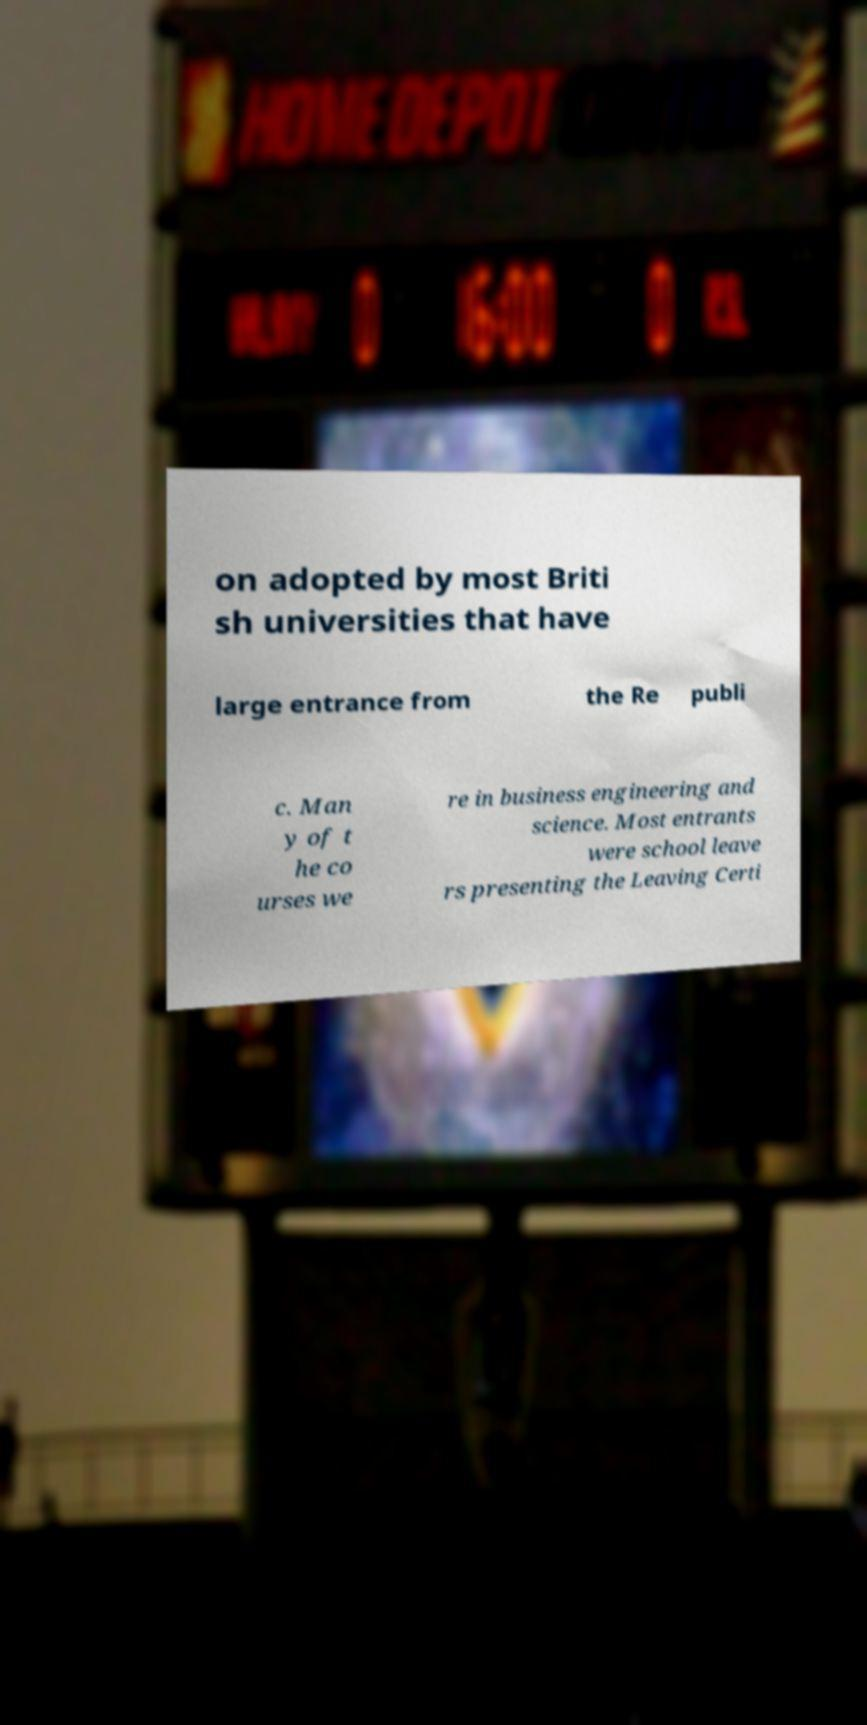Can you accurately transcribe the text from the provided image for me? on adopted by most Briti sh universities that have large entrance from the Re publi c. Man y of t he co urses we re in business engineering and science. Most entrants were school leave rs presenting the Leaving Certi 